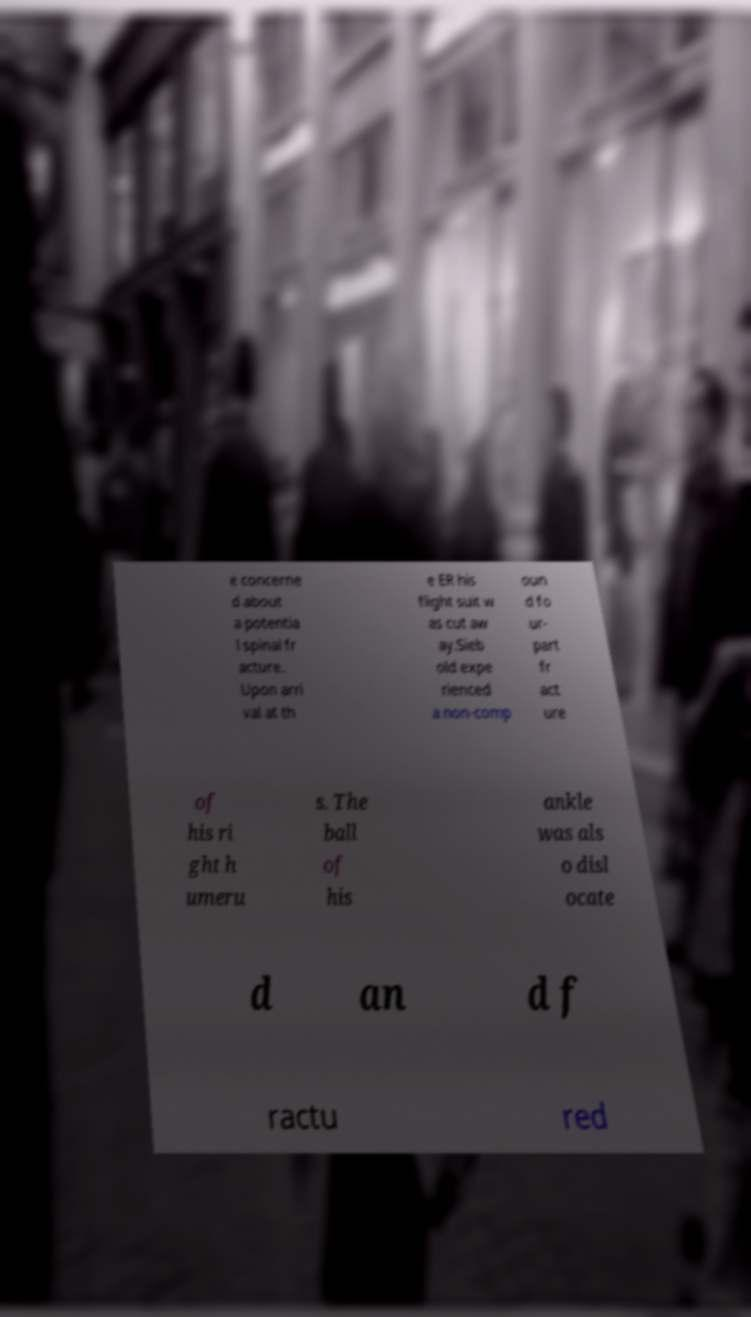Can you read and provide the text displayed in the image?This photo seems to have some interesting text. Can you extract and type it out for me? e concerne d about a potentia l spinal fr acture. Upon arri val at th e ER his flight suit w as cut aw ay.Sieb old expe rienced a non-comp oun d fo ur- part fr act ure of his ri ght h umeru s. The ball of his ankle was als o disl ocate d an d f ractu red 